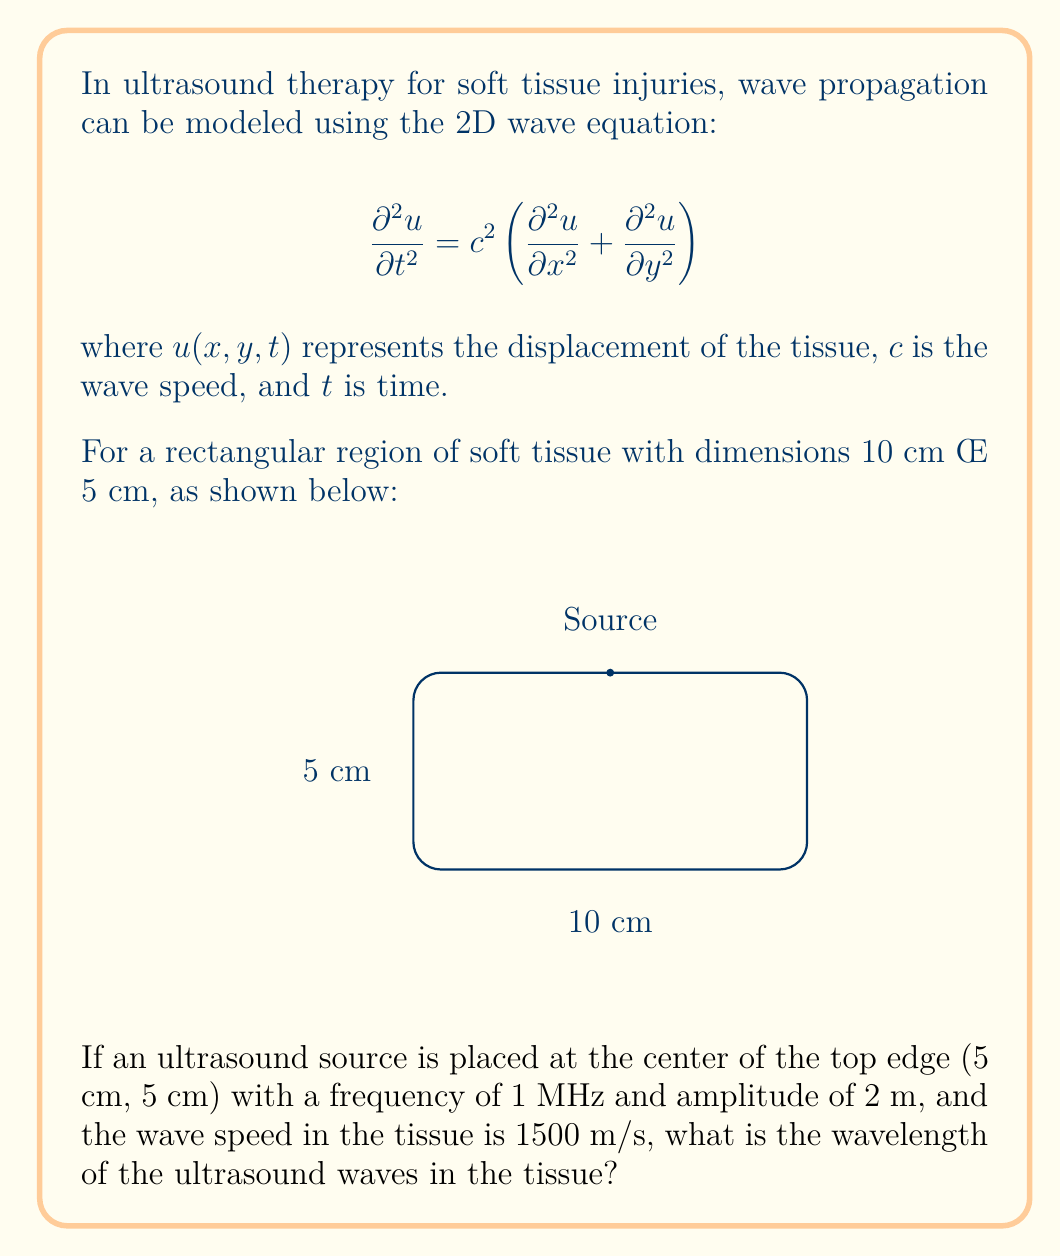Solve this math problem. To solve this problem, we need to use the relationship between wavelength, frequency, and wave speed. The steps are as follows:

1) The general equation relating wavelength ($\lambda$), frequency ($f$), and wave speed ($c$) is:

   $$c = f \lambda$$

2) We are given:
   - Frequency, $f = 1 \text{ MHz} = 1 \times 10^6 \text{ Hz}$
   - Wave speed, $c = 1500 \text{ m/s}$

3) Substituting these values into the equation:

   $$1500 = (1 \times 10^6) \lambda$$

4) Solving for $\lambda$:

   $$\lambda = \frac{1500}{1 \times 10^6} = 1.5 \times 10^{-3} \text{ m}$$

5) Converting to millimeters for a more practical unit in physiotherapy:

   $$\lambda = 1.5 \text{ mm}$$

This wavelength is typical for ultrasound therapy in soft tissues, allowing for localized energy deposition and precise targeting of injured areas.
Answer: $1.5 \text{ mm}$ 